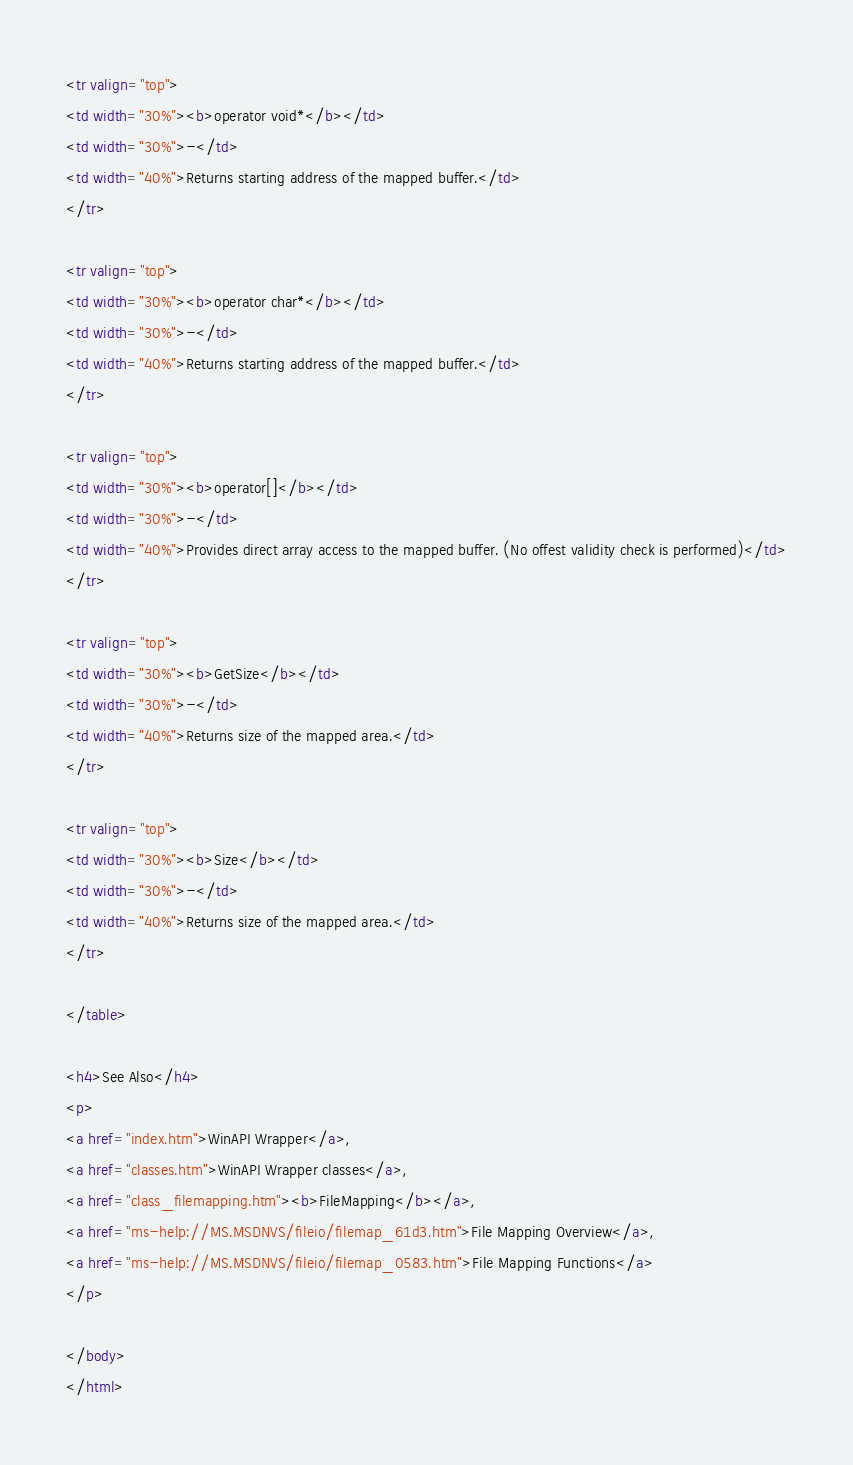<code> <loc_0><loc_0><loc_500><loc_500><_HTML_>
<tr valign="top">
<td width="30%"><b>operator void*</b></td>
<td width="30%">-</td>
<td width="40%">Returns starting address of the mapped buffer.</td>
</tr>

<tr valign="top">
<td width="30%"><b>operator char*</b></td>
<td width="30%">-</td>
<td width="40%">Returns starting address of the mapped buffer.</td>
</tr>

<tr valign="top">
<td width="30%"><b>operator[]</b></td>
<td width="30%">-</td>
<td width="40%">Provides direct array access to the mapped buffer. (No offest validity check is performed)</td>
</tr>

<tr valign="top">
<td width="30%"><b>GetSize</b></td>
<td width="30%">-</td>
<td width="40%">Returns size of the mapped area.</td>
</tr>

<tr valign="top">
<td width="30%"><b>Size</b></td>
<td width="30%">-</td>
<td width="40%">Returns size of the mapped area.</td>
</tr>

</table>

<h4>See Also</h4>
<p>
<a href="index.htm">WinAPI Wrapper</a>,
<a href="classes.htm">WinAPI Wrapper classes</a>,
<a href="class_filemapping.htm"><b>FileMapping</b></a>,
<a href="ms-help://MS.MSDNVS/fileio/filemap_61d3.htm">File Mapping Overview</a>,
<a href="ms-help://MS.MSDNVS/fileio/filemap_0583.htm">File Mapping Functions</a>
</p>

</body>
</html>
</code> 